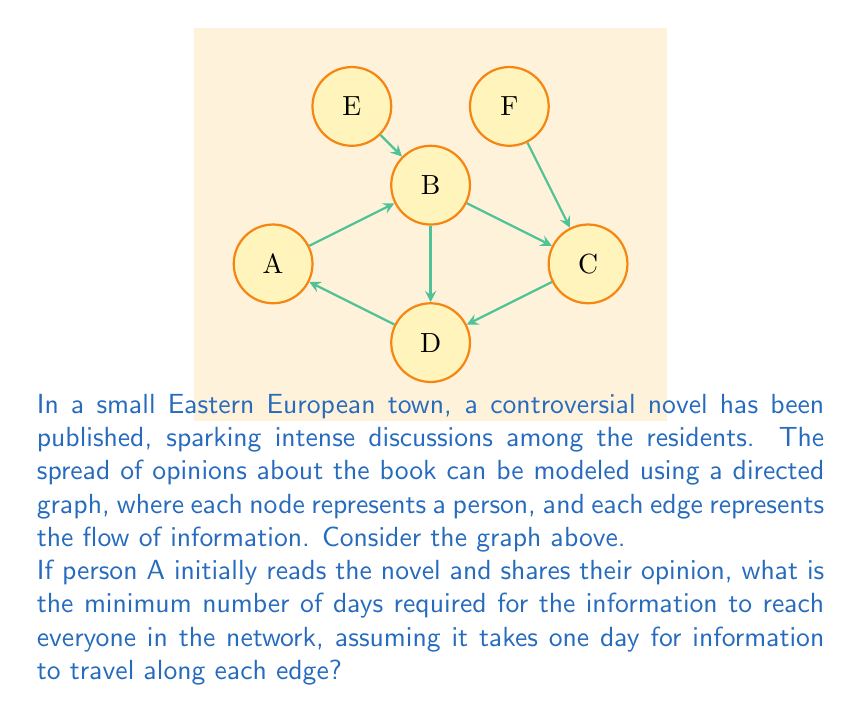Show me your answer to this math problem. To solve this problem, we need to find the longest path from node A to any other node in the graph. This is because the information needs to reach every person, and the time taken is determined by the person who receives the information last.

Let's analyze the paths from A to each node:

1. A to B: 1 day
2. A to C: A → B → C = 2 days
3. A to D: 1 day
4. A to E: No path (E only gives information, doesn't receive)
5. A to F: No path (F only gives information, doesn't receive)

The longest path is from A to C, which takes 2 days.

To verify that this is indeed the minimum number of days required, let's check if all nodes (except E and F) can be reached within 2 days:

Day 1:
- A shares with B and D

Day 2:
- B shares with C

At the end of Day 2, all reachable nodes (A, B, C, D) have received the information.

Therefore, the minimum number of days required for the information to reach everyone in the network is 2 days.
Answer: 2 days 